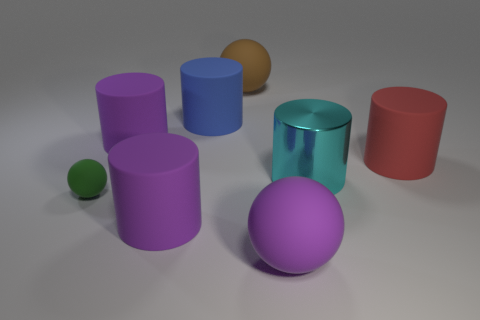How many gray cylinders are there?
Ensure brevity in your answer.  0. There is a large rubber ball that is in front of the big brown rubber thing; is it the same color as the large cylinder in front of the big cyan metal object?
Provide a short and direct response. Yes. There is a small green matte ball; what number of large spheres are behind it?
Your answer should be compact. 1. Is there a green matte object of the same shape as the big brown thing?
Offer a terse response. Yes. Is the material of the ball on the left side of the big brown ball the same as the large cyan thing behind the green rubber thing?
Your answer should be compact. No. There is a matte sphere on the left side of the big purple cylinder on the right side of the large purple matte object behind the small green thing; what size is it?
Your answer should be very brief. Small. There is a blue cylinder that is the same size as the red cylinder; what is it made of?
Keep it short and to the point. Rubber. Are there any matte spheres that have the same size as the cyan object?
Provide a succinct answer. Yes. Is the shape of the tiny green rubber thing the same as the red thing?
Your answer should be very brief. No. Is there a cylinder in front of the large matte ball that is to the right of the thing behind the large blue cylinder?
Keep it short and to the point. No. 